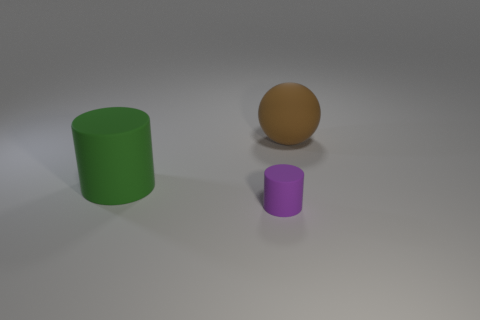What is the thing that is in front of the big rubber thing in front of the object that is on the right side of the tiny purple thing made of?
Provide a short and direct response. Rubber. How many things are big brown matte objects or big rubber objects?
Ensure brevity in your answer.  2. What is the shape of the green object that is the same size as the brown rubber sphere?
Provide a short and direct response. Cylinder. What number of objects are either objects to the left of the brown rubber sphere or big things to the right of the purple cylinder?
Ensure brevity in your answer.  3. Are there fewer cyan objects than large green rubber objects?
Provide a short and direct response. Yes. There is a brown object that is the same size as the green matte object; what is its material?
Your answer should be compact. Rubber. Is the size of the rubber object right of the purple rubber thing the same as the rubber thing in front of the green cylinder?
Offer a very short reply. No. Are there any small purple objects made of the same material as the brown sphere?
Provide a short and direct response. Yes. What number of things are either things right of the small cylinder or tiny yellow rubber blocks?
Offer a terse response. 1. Is the object right of the small purple matte object made of the same material as the small purple cylinder?
Offer a terse response. Yes. 